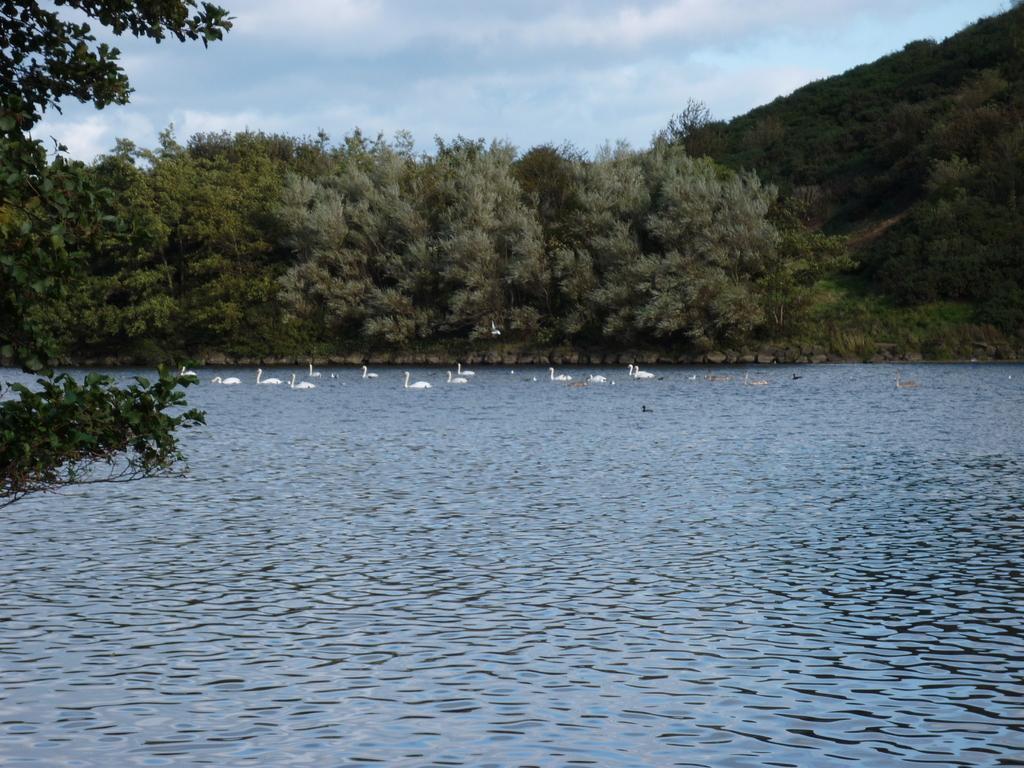In one or two sentences, can you explain what this image depicts? In this picture we can see birds on the water, trees and hill. In the background of the image we can see the sky. 